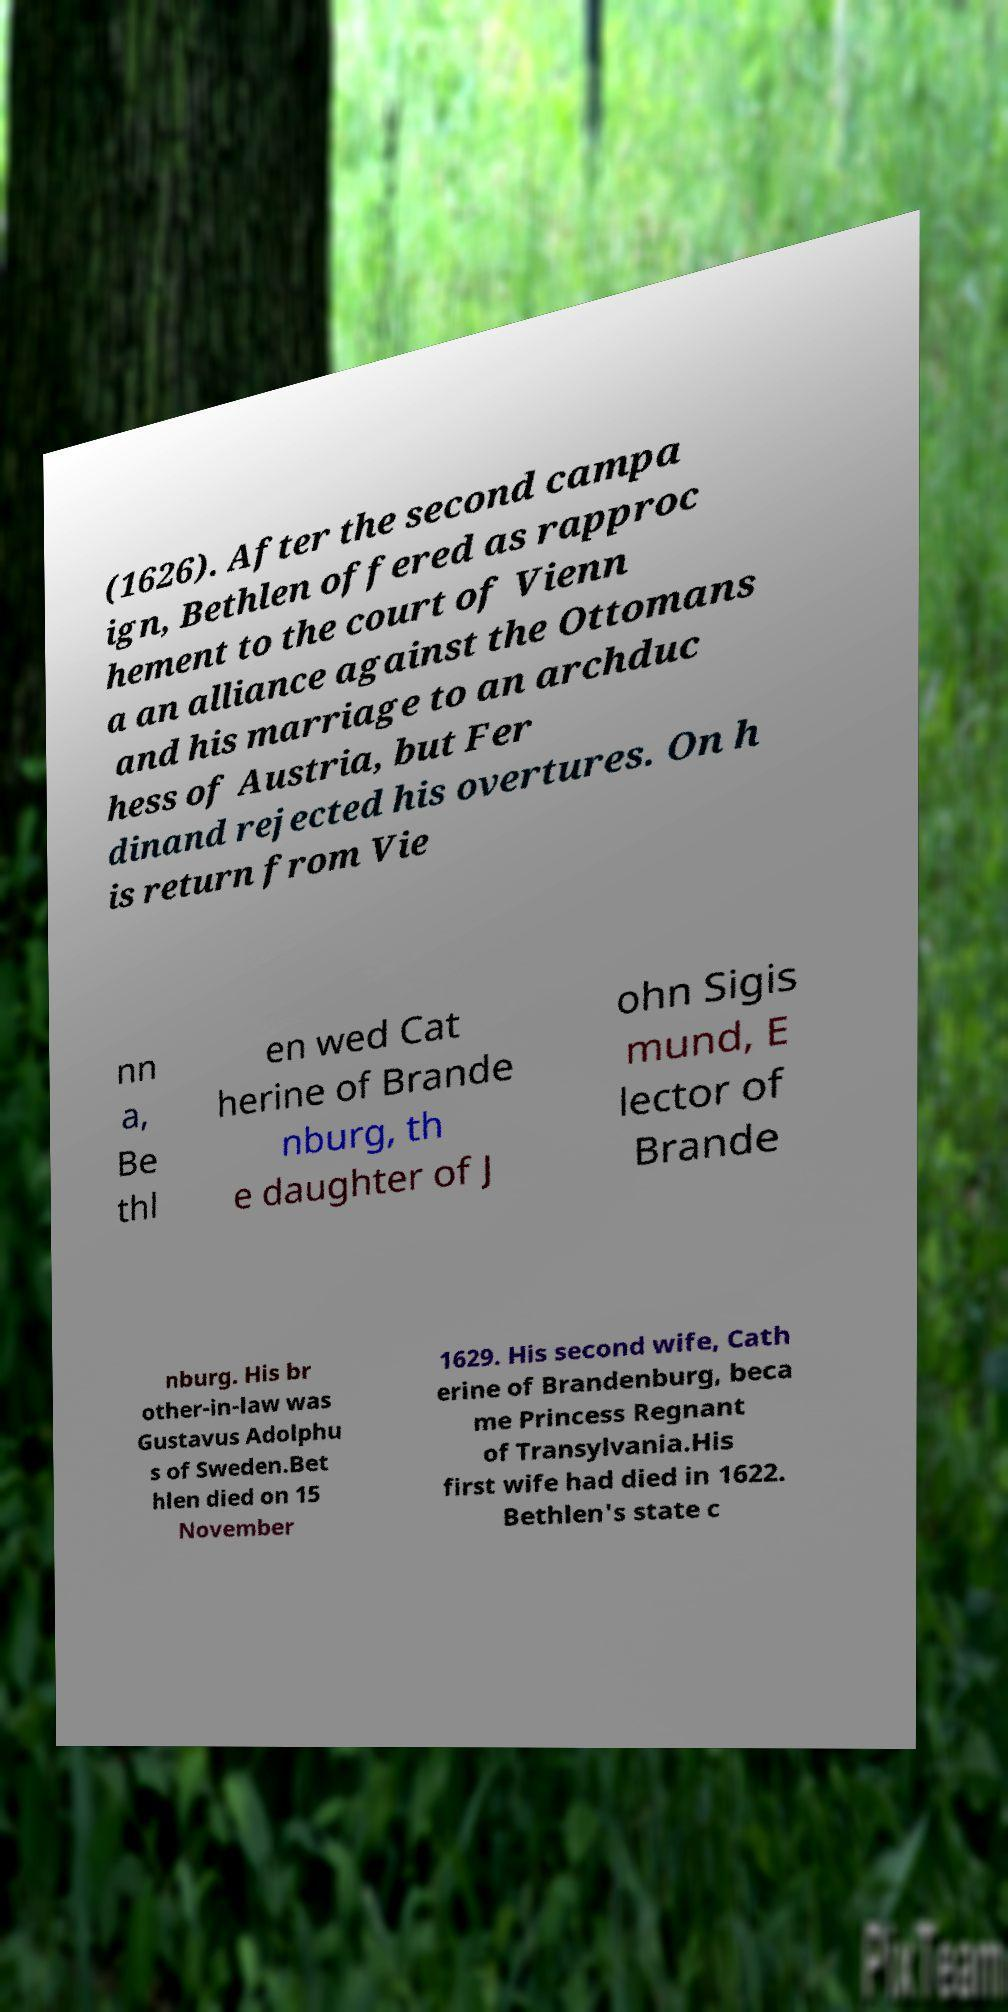For documentation purposes, I need the text within this image transcribed. Could you provide that? (1626). After the second campa ign, Bethlen offered as rapproc hement to the court of Vienn a an alliance against the Ottomans and his marriage to an archduc hess of Austria, but Fer dinand rejected his overtures. On h is return from Vie nn a, Be thl en wed Cat herine of Brande nburg, th e daughter of J ohn Sigis mund, E lector of Brande nburg. His br other-in-law was Gustavus Adolphu s of Sweden.Bet hlen died on 15 November 1629. His second wife, Cath erine of Brandenburg, beca me Princess Regnant of Transylvania.His first wife had died in 1622. Bethlen's state c 